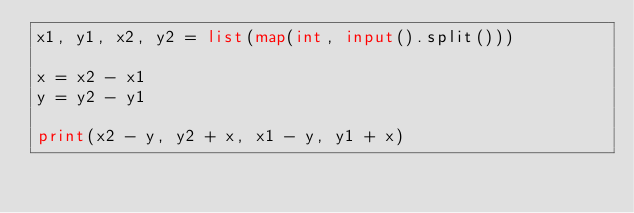Convert code to text. <code><loc_0><loc_0><loc_500><loc_500><_Python_>x1, y1, x2, y2 = list(map(int, input().split()))

x = x2 - x1
y = y2 - y1

print(x2 - y, y2 + x, x1 - y, y1 + x)

</code> 